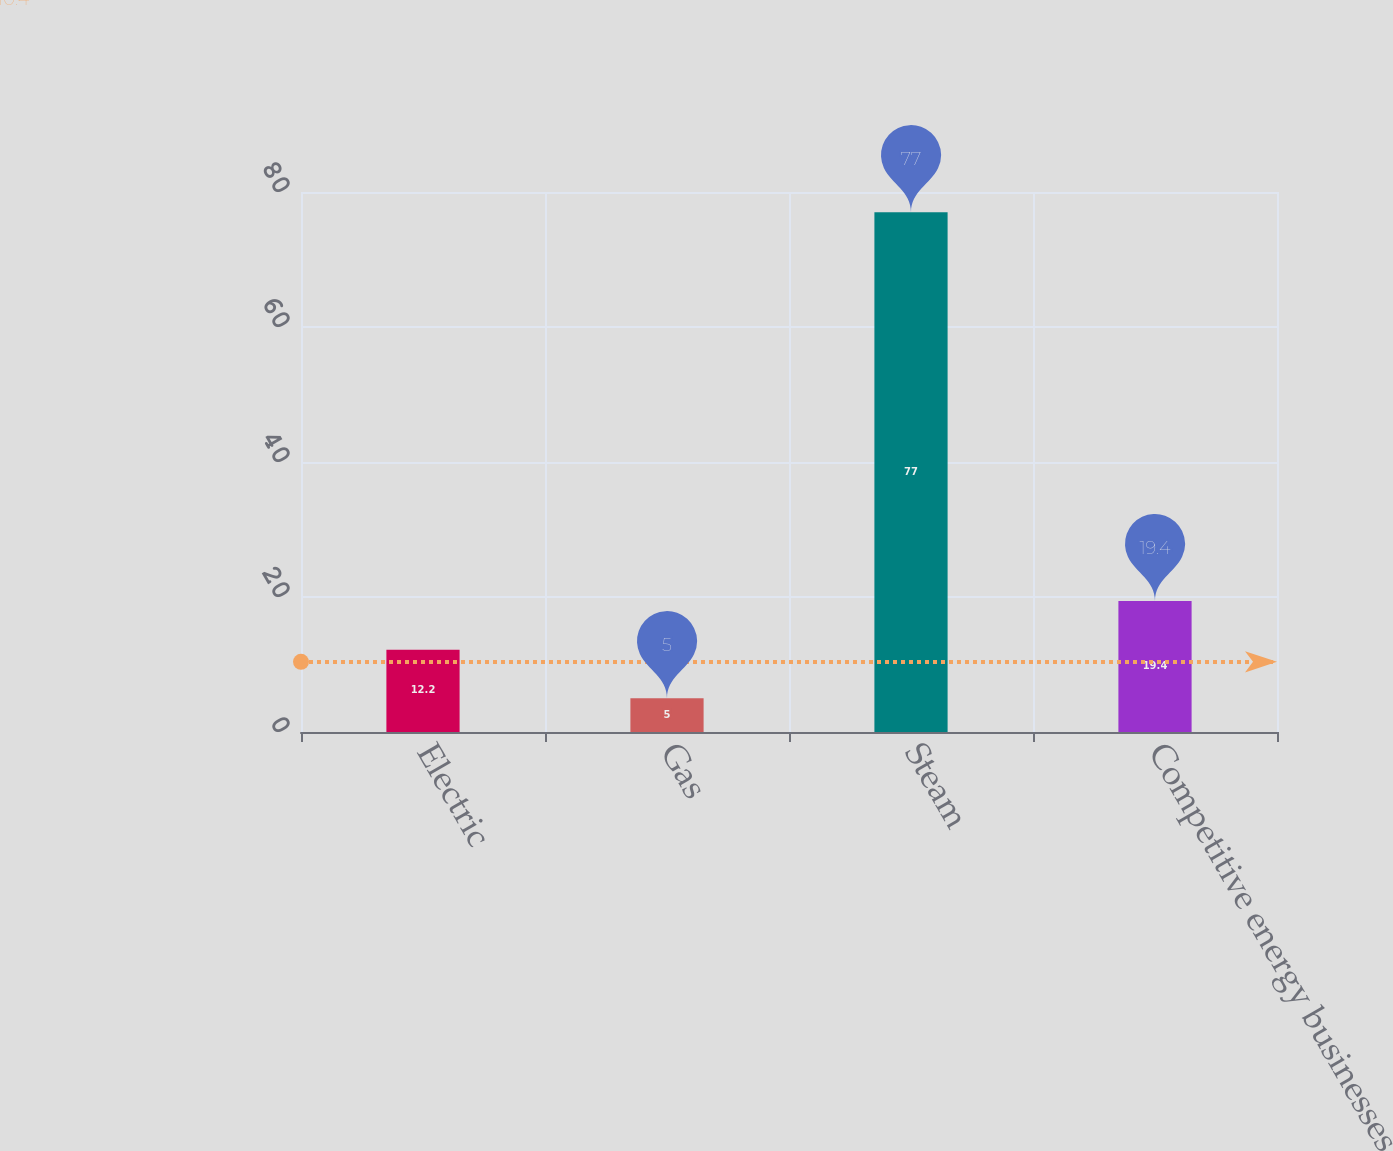<chart> <loc_0><loc_0><loc_500><loc_500><bar_chart><fcel>Electric<fcel>Gas<fcel>Steam<fcel>Competitive energy businesses<nl><fcel>12.2<fcel>5<fcel>77<fcel>19.4<nl></chart> 